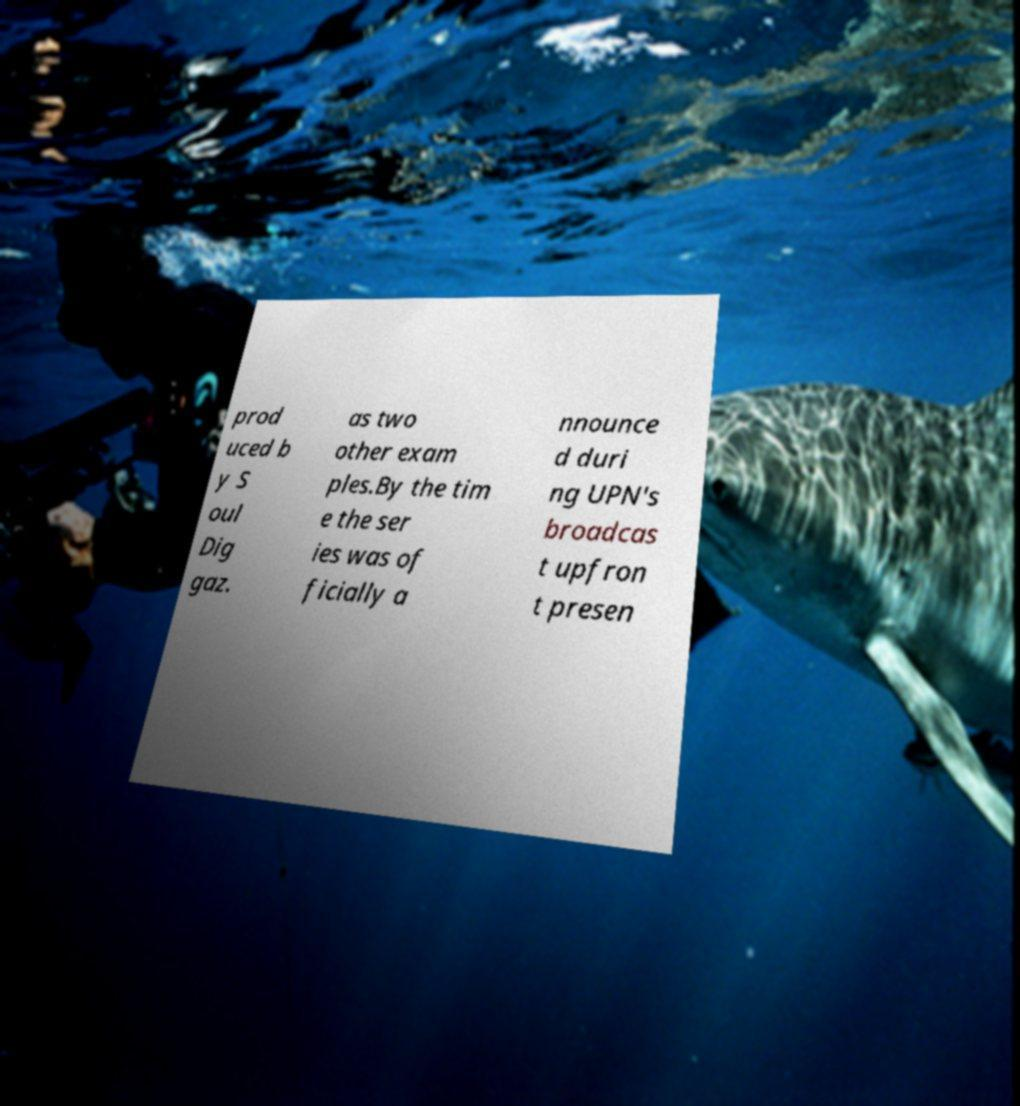Please identify and transcribe the text found in this image. prod uced b y S oul Dig gaz. as two other exam ples.By the tim e the ser ies was of ficially a nnounce d duri ng UPN's broadcas t upfron t presen 